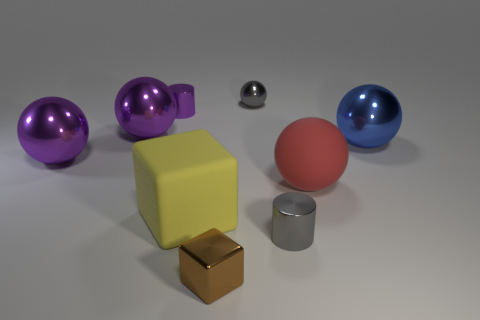There is a shiny cylinder behind the tiny gray metallic cylinder; does it have the same color as the large ball that is behind the large blue sphere?
Provide a short and direct response. Yes. There is a object that is the same color as the tiny metal sphere; what is its shape?
Give a very brief answer. Cylinder. How many other large shiny objects are the same shape as the yellow thing?
Offer a terse response. 0. There is a shiny sphere on the right side of the tiny metallic cylinder in front of the small purple cylinder; how big is it?
Keep it short and to the point. Large. What number of gray things are matte spheres or large things?
Make the answer very short. 0. Is the number of big red things on the right side of the big red thing less than the number of large yellow things left of the tiny block?
Make the answer very short. Yes. Is the size of the blue metallic thing the same as the rubber thing to the left of the red ball?
Your response must be concise. Yes. What number of other rubber spheres are the same size as the blue ball?
Offer a terse response. 1. How many large objects are purple metal balls or yellow things?
Your response must be concise. 3. Are there any large brown spheres?
Make the answer very short. No. 